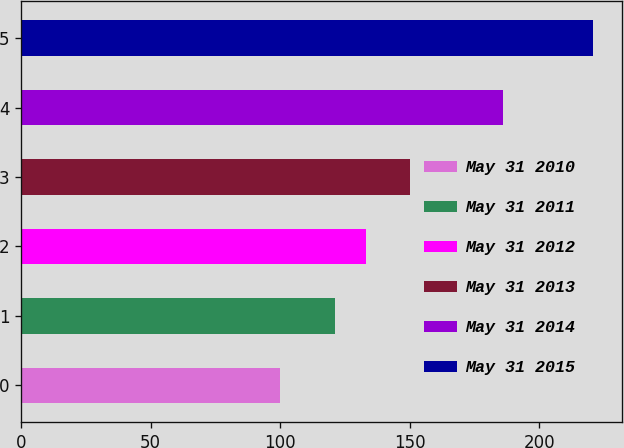Convert chart. <chart><loc_0><loc_0><loc_500><loc_500><bar_chart><fcel>May 31 2010<fcel>May 31 2011<fcel>May 31 2012<fcel>May 31 2013<fcel>May 31 2014<fcel>May 31 2015<nl><fcel>100<fcel>121.13<fcel>133.21<fcel>150<fcel>185.84<fcel>220.8<nl></chart> 